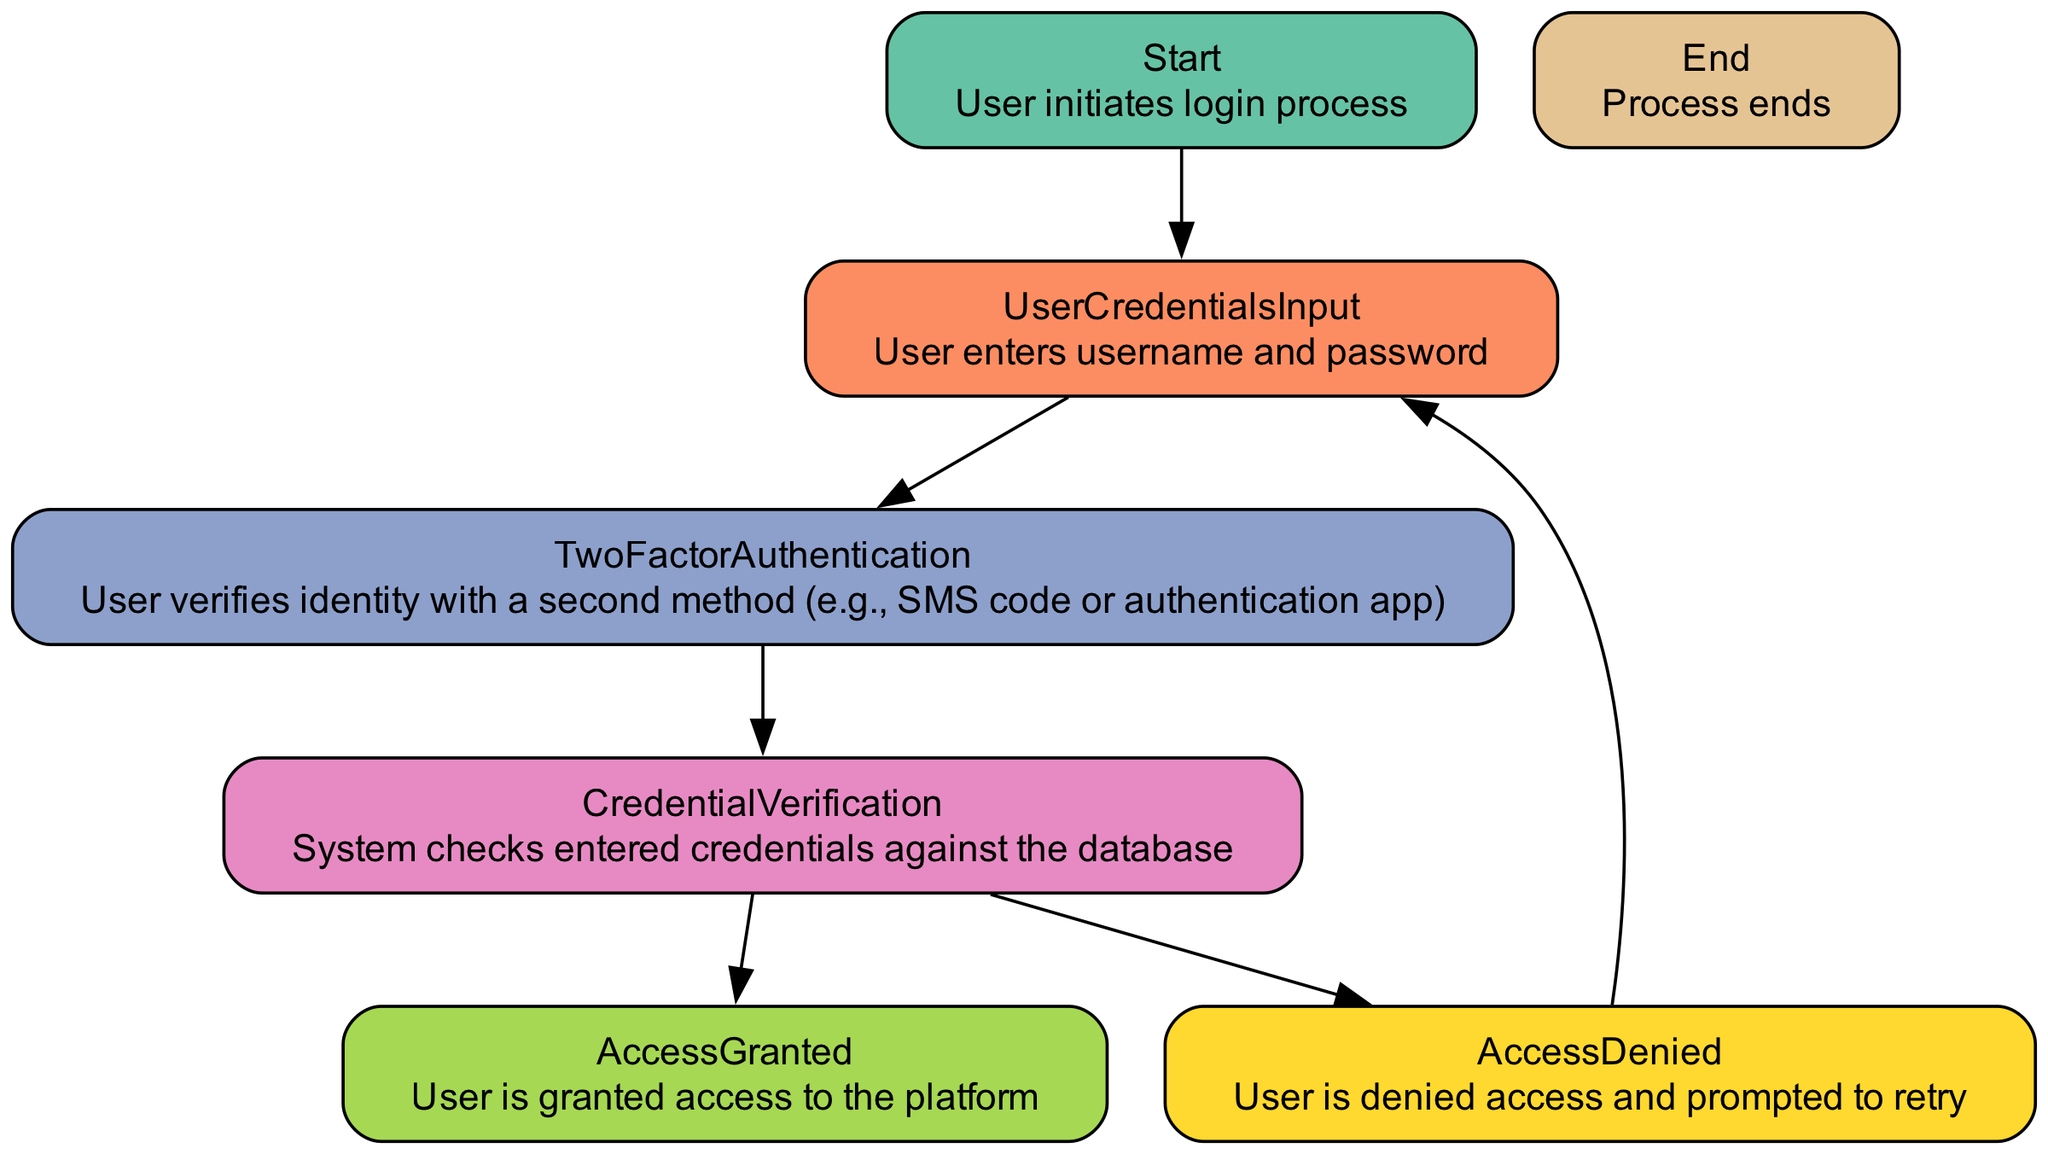What is the starting node of the workflow? The starting node is labeled "Start," which indicates the initiation of the login process.
Answer: Start How many nodes are there in total? Counting each labeled node in the workflow, there are seven distinct nodes: Start, UserCredentialsInput, TwoFactorAuthentication, CredentialVerification, AccessGranted, AccessDenied, and End.
Answer: 7 What is the next node after "UserCredentialsInput"? The next node following "UserCredentialsInput" is "TwoFactorAuthentication," indicating the progression in the workflow after entering the credentials.
Answer: TwoFactorAuthentication How many possible paths are there from "CredentialVerification"? From "CredentialVerification," there are two possible paths: "AccessGranted" and "AccessDenied." This means there are two distinct outcomes that can follow this step in the workflow.
Answer: 2 What color represents "AccessGranted"? "AccessGranted" is represented in green (#a6d854), highlighting the successful outcome of the authentication process.
Answer: green What happens if the credentials are incorrect? If the credentials are incorrect, the user is directed to "AccessDenied," which then prompts them to "UserCredentialsInput" again for re-entry of username and password.
Answer: AccessDenied Which node directly follows "TwoFactorAuthentication"? The node that directly follows "TwoFactorAuthentication" in the workflow is "CredentialVerification," indicating that after verifying identity with a second method, the system checks the credentials.
Answer: CredentialVerification How many edges connect to the "End" node? The "End" node receives one edge from "AccessGranted," indicating that the process concludes successfully after access has been granted.
Answer: 1 